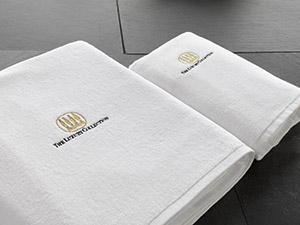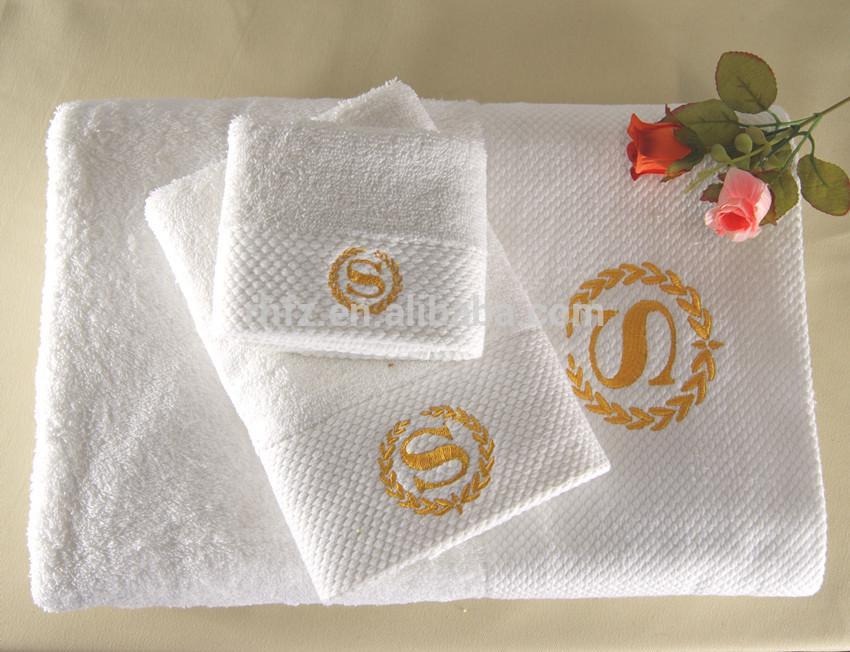The first image is the image on the left, the second image is the image on the right. Considering the images on both sides, is "The left image shows three white towels with the Sheraton logo stacked on top of each other." valid? Answer yes or no. Yes. The first image is the image on the left, the second image is the image on the right. Considering the images on both sides, is "In one of the images, four towels are stacked in a single stack." valid? Answer yes or no. No. 